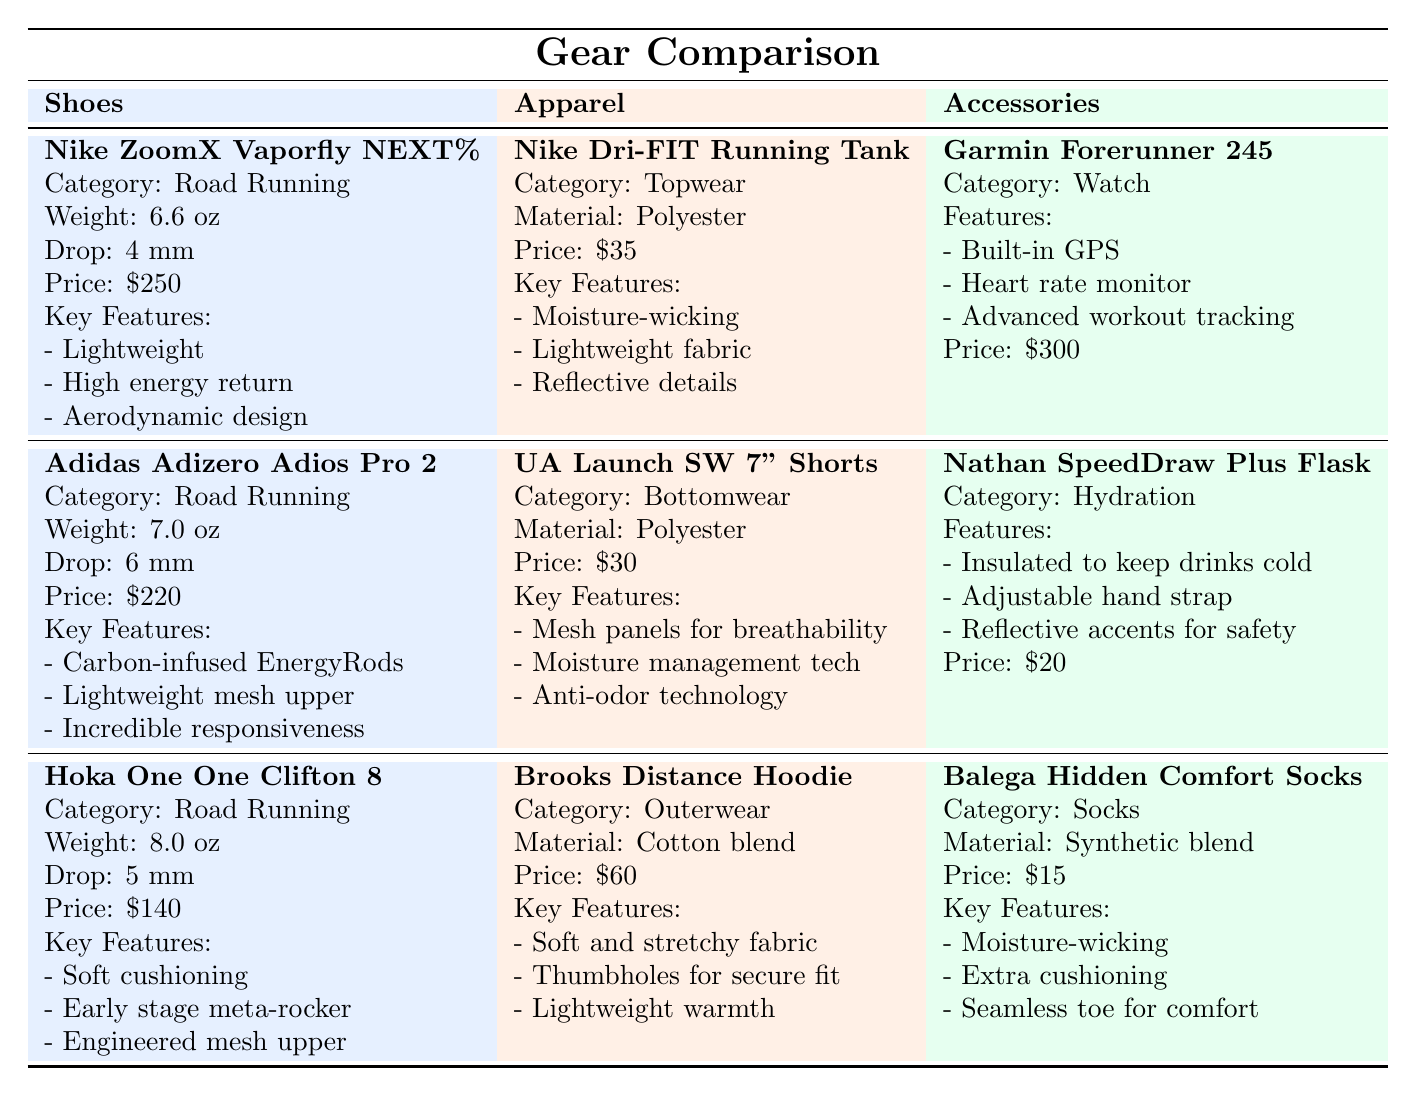What is the weight of the Nike ZoomX Vaporfly NEXT%? The table specifies that the Nike ZoomX Vaporfly NEXT% has a weight of 6.6 oz listed under the Shoes category.
Answer: 6.6 oz Which shoe has the highest price? The prices of the shoes are: Nike ZoomX Vaporfly NEXT% for $250, Adidas Adizero Adios Pro 2 for $220, and Hoka One One Clifton 8 for $140. The highest of these is $250 for the Nike ZoomX Vaporfly NEXT%.
Answer: $250 What is the drop of the Adidas Adizero Adios Pro 2? The table indicates that the drop of the Adidas Adizero Adios Pro 2 is 6 mm, which is specified in the Shoes section of the table.
Answer: 6 mm Is the Brooks Distance Hoodie made of polyester? The table states that the Brooks Distance Hoodie is made of a cotton blend, not polyester, which is indicated in the Apparel category.
Answer: No What is the total price of the shoes listed? The prices of the shoes are: $250 (Nike ZoomX Vaporfly NEXT%), $220 (Adidas Adizero Adios Pro 2), and $140 (Hoka One One Clifton 8). Adding these gives $250 + $220 + $140 = $610.
Answer: $610 Which accessory has features related to hydration? The Nathan SpeedDraw Plus Insulated Flask is categorized under Hydration in the Accessories section and is highlighted with features specifically focused on keeping drinks cold.
Answer: Nathan SpeedDraw Plus Insulated Flask What is the average weight of the shoes listed? The weights of the shoes are: 6.6 oz (Nike ZoomX Vaporfly NEXT%), 7.0 oz (Adidas Adizero Adios Pro 2), and 8.0 oz (Hoka One One Clifton 8). Sum the values (6.6 + 7.0 + 8.0) = 21.6 oz and then divide by 3 for the average: 21.6 oz ÷ 3 = 7.2 oz.
Answer: 7.2 oz Which apparel item has moisture-wicking properties? The Nike Dri-FIT Running Tank is listed with the feature of moisture-wicking in the Apparel section.
Answer: Nike Dri-FIT Running Tank What is the price difference between the most expensive and the least expensive accessory? The Garmin Forerunner 245 is $300, and the Balega Hidden Comfort Socks are $15. The price difference is calculated as $300 - $15 = $285.
Answer: $285 